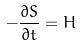<formula> <loc_0><loc_0><loc_500><loc_500>- \frac { \partial S } { \partial t } = H</formula> 